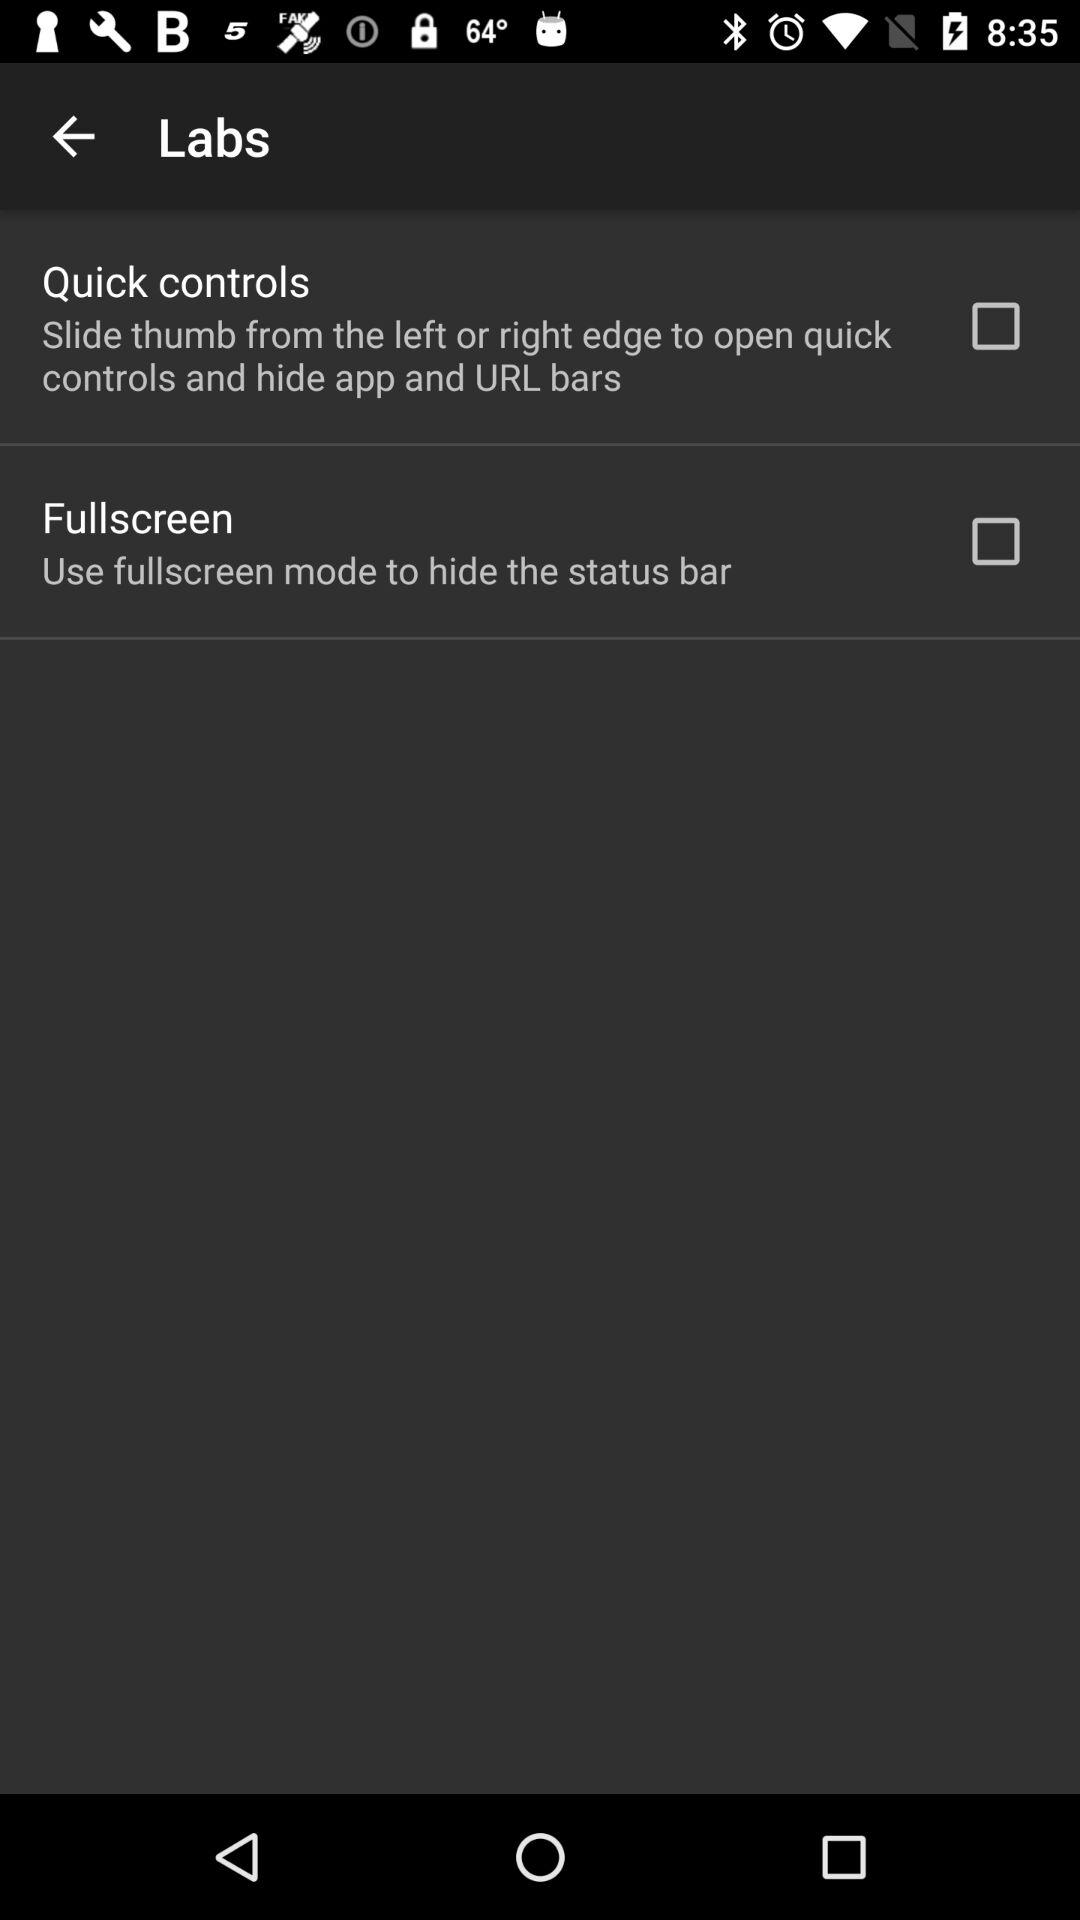What is the status of "Quick controls"? The status of "Quick controls" is off. 